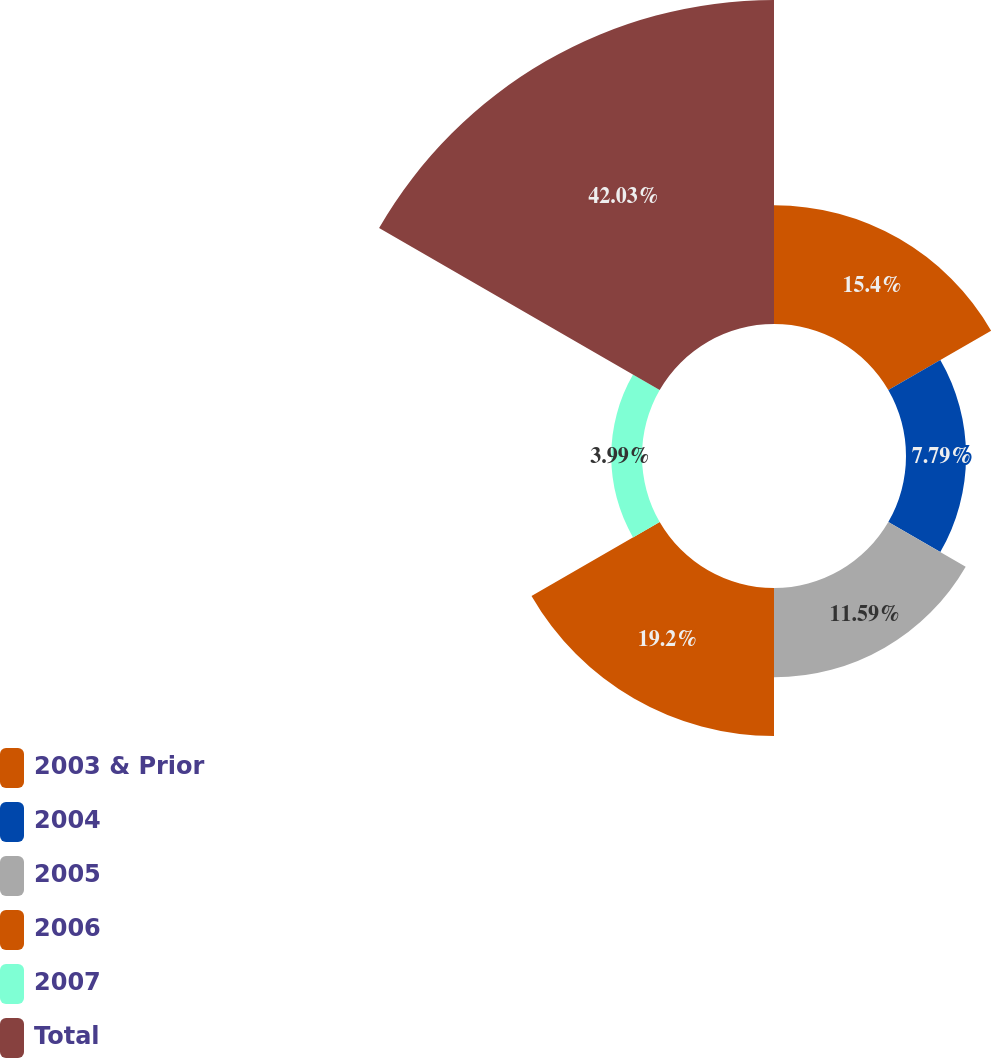<chart> <loc_0><loc_0><loc_500><loc_500><pie_chart><fcel>2003 & Prior<fcel>2004<fcel>2005<fcel>2006<fcel>2007<fcel>Total<nl><fcel>15.4%<fcel>7.79%<fcel>11.59%<fcel>19.2%<fcel>3.99%<fcel>42.03%<nl></chart> 